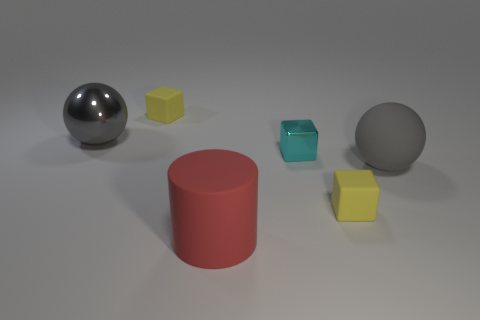Subtract all green balls. How many yellow blocks are left? 2 Add 2 tiny matte cylinders. How many objects exist? 8 Subtract all tiny rubber cubes. How many cubes are left? 1 Add 2 large cyan shiny blocks. How many large cyan shiny blocks exist? 2 Subtract 2 gray balls. How many objects are left? 4 Subtract all balls. How many objects are left? 4 Subtract all yellow metal cylinders. Subtract all large metal things. How many objects are left? 5 Add 4 big gray rubber spheres. How many big gray rubber spheres are left? 5 